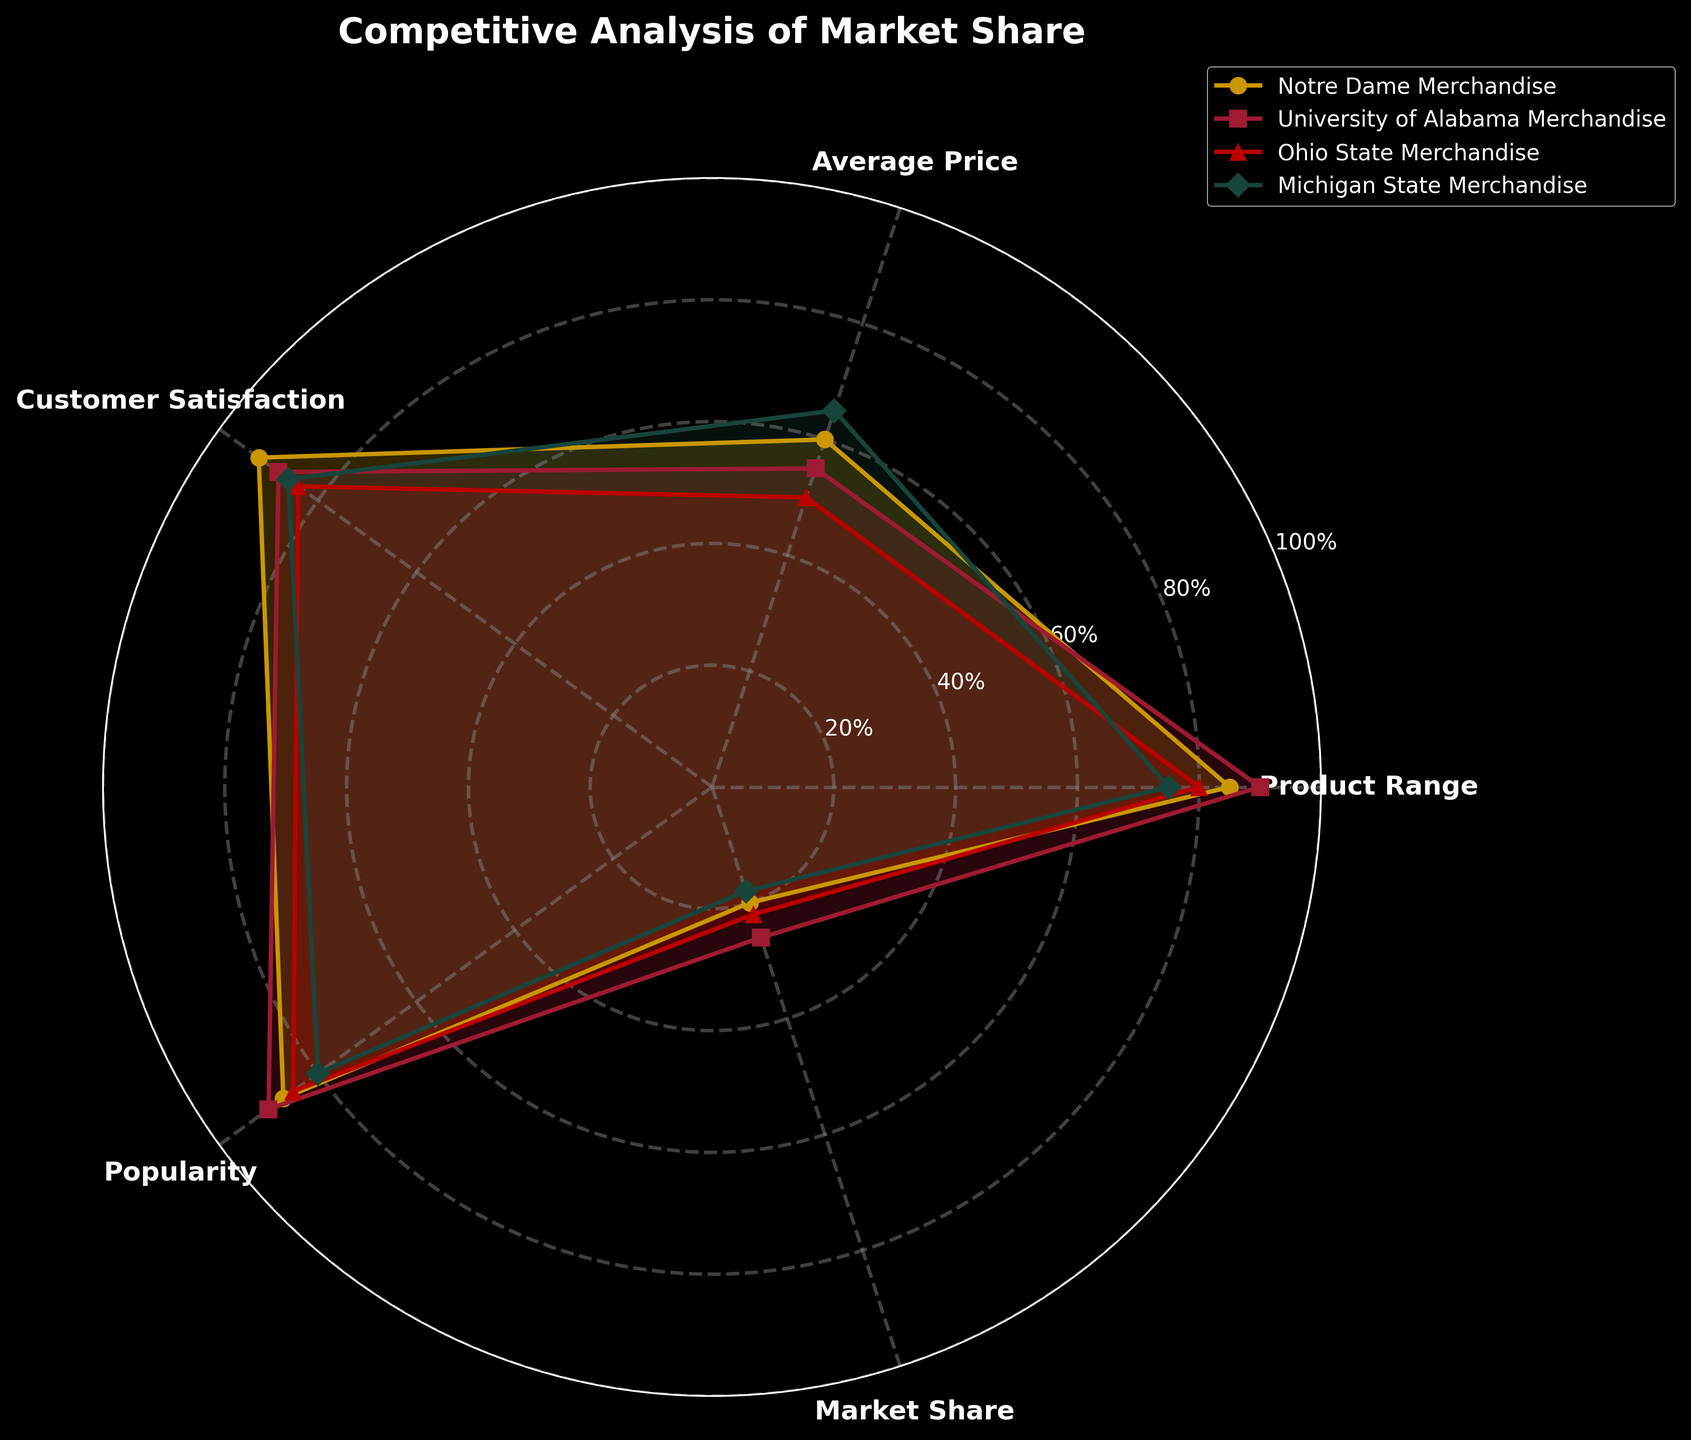What is the title of the radar chart? The title of the chart is at the top and reads "Competitive Analysis of Market Share".
Answer: Competitive Analysis of Market Share Which group has the highest customer satisfaction? By examining the Customer Satisfaction axis, Notre Dame Merchandise has the highest value at 92%.
Answer: Notre Dame Merchandise How does the University of Alabama Merchandise compare in terms of popularity and market share? University of Alabama Merchandise has a popularity of 90% and a market share of 26%, as seen along their respective axes.
Answer: Popularity: 90%, Market Share: 26% Out of the four categories, which one does Notre Dame Merchandise score the lowest in? Notre Dame Merchandise scores 60% in the Average Price category, which is the lowest among the five categories.
Answer: Average Price What is the average market share across all four groups? Sum the market share percentages (20% + 26% + 22% + 18%) to get 86%, then divide by 4 to get the average market share.
Answer: 21.5% Which merchandise has the lowest average price? By looking at the Average Price axis, Ohio State Merchandise has the lowest value at 50%.
Answer: Ohio State Merchandise Compare the product range of Notre Dame Merchandise and Michigan State Merchandise. Which is higher and by how much? Notre Dame Merchandise has a product range of 85%, while Michigan State Merchandise has 75%. The difference is 85% - 75% = 10%.
Answer: Notre Dame by 10% What is the sum of the popularity scores for all groups? Adding the popularity scores: 87% (Notre Dame) + 90% (University of Alabama) + 85% (Ohio State) + 80% (Michigan State) = 342%.
Answer: 342% Between Ohio State Merchandise and Michigan State Merchandise, which has higher customer satisfaction, and by what margin? Ohio State has 84% while Michigan State has 86%. The margin is 86% - 84% = 2%.
Answer: Michigan State by 2% How do the market shares of Notre Dame Merchandise and Ohio State Merchandise compare? Notre Dame Merchandise has a market share of 20%, and Ohio State Merchandise has 22%. Ohio State Merchandise's share is 2% higher.
Answer: Ohio State Merchandise by 2% 